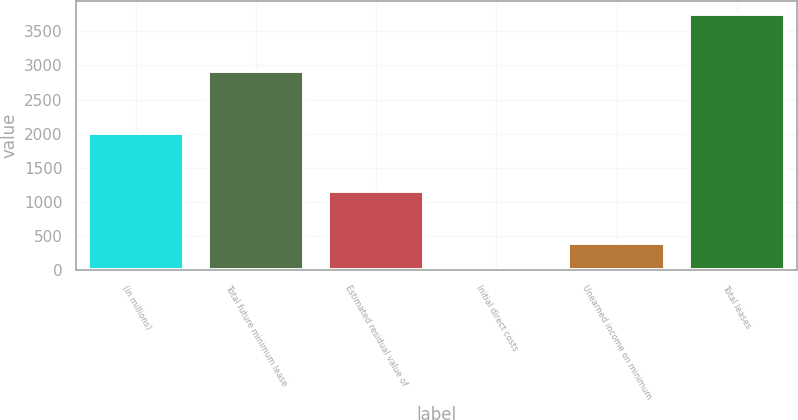Convert chart. <chart><loc_0><loc_0><loc_500><loc_500><bar_chart><fcel>(in millions)<fcel>Total future minimum lease<fcel>Estimated residual value of<fcel>Initial direct costs<fcel>Unearned income on minimum<fcel>Total leases<nl><fcel>2016<fcel>2922<fcel>1166<fcel>20<fcel>393.3<fcel>3753<nl></chart> 